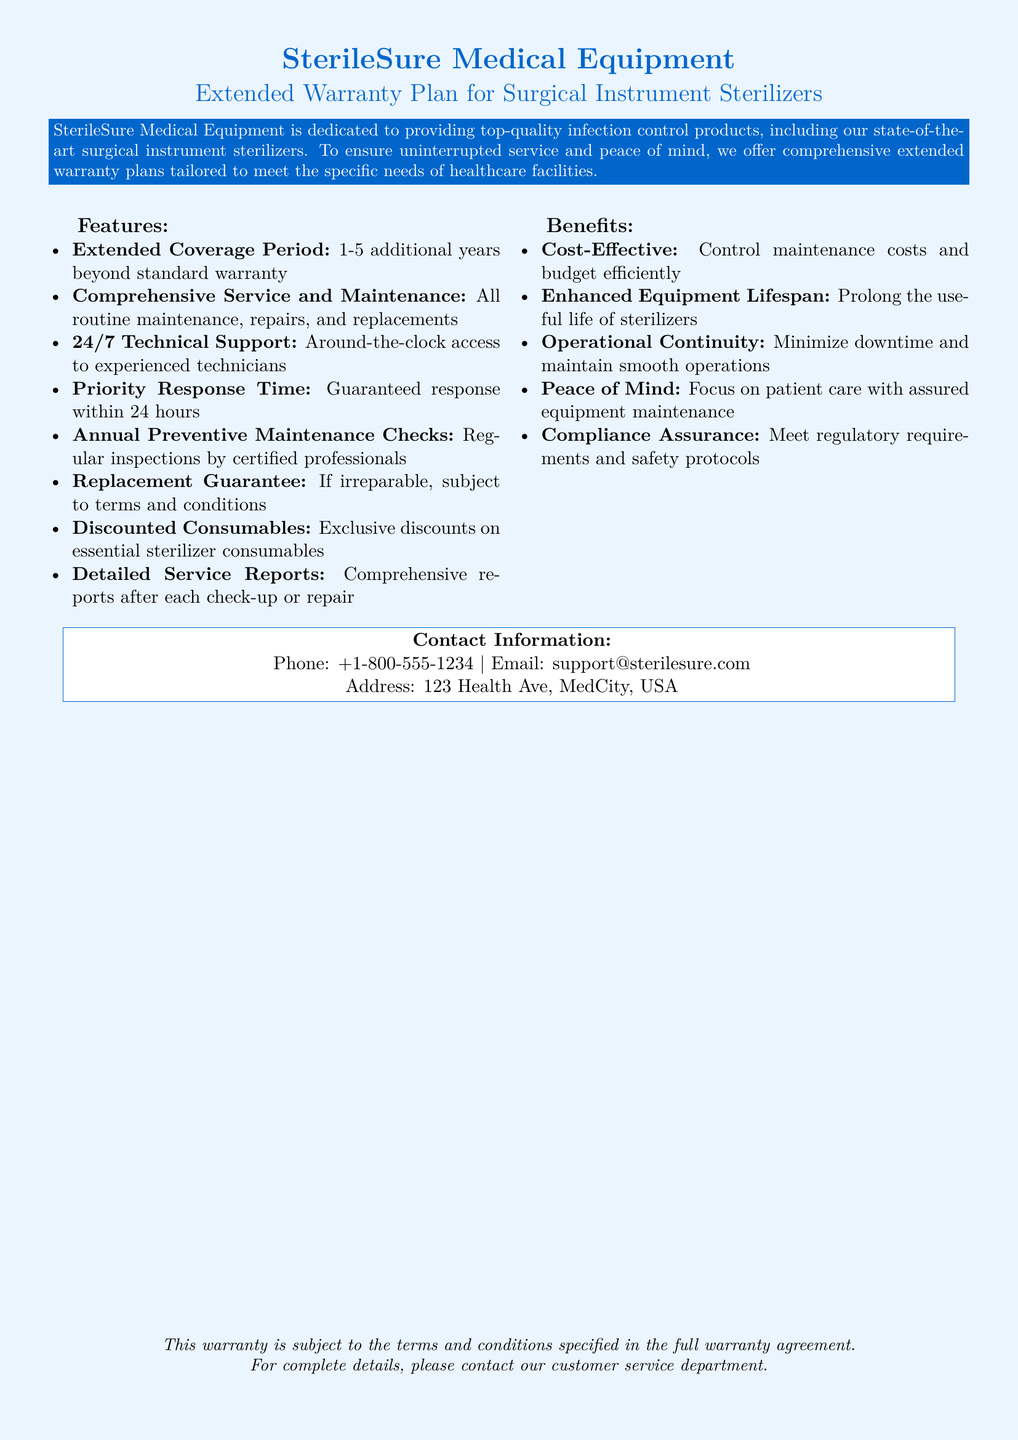What is the coverage period for the extended warranty? The document states that the extended warranty covers 1-5 additional years beyond the standard warranty.
Answer: 1-5 additional years What type of support is available 24/7? The document specifies that there is 24/7 technical support with experienced technicians.
Answer: Technical support What is the guaranteed response time for service requests? According to the document, there is a priority response time guaranteed within 24 hours.
Answer: 24 hours What benefit is highlighted regarding operational continuity? The document mentions that the extended warranty minimizes downtime and maintains smooth operations.
Answer: Minimize downtime What is included in annual preventive maintenance checks? The document states that regular inspections are conducted by certified professionals during annual preventive maintenance checks.
Answer: Inspections by certified professionals What kind of reports are provided after each check-up or repair? The document indicates that detailed service reports are provided after each check-up or repair.
Answer: Service reports What is the main focus customers can have with the extended warranty? The document assures that customers can focus on patient care with assured equipment maintenance.
Answer: Focus on patient care What kind of discounts are included in the warranty plan? The document states there are exclusive discounts on essential sterilizer consumables.
Answer: Exclusive discounts on consumables 